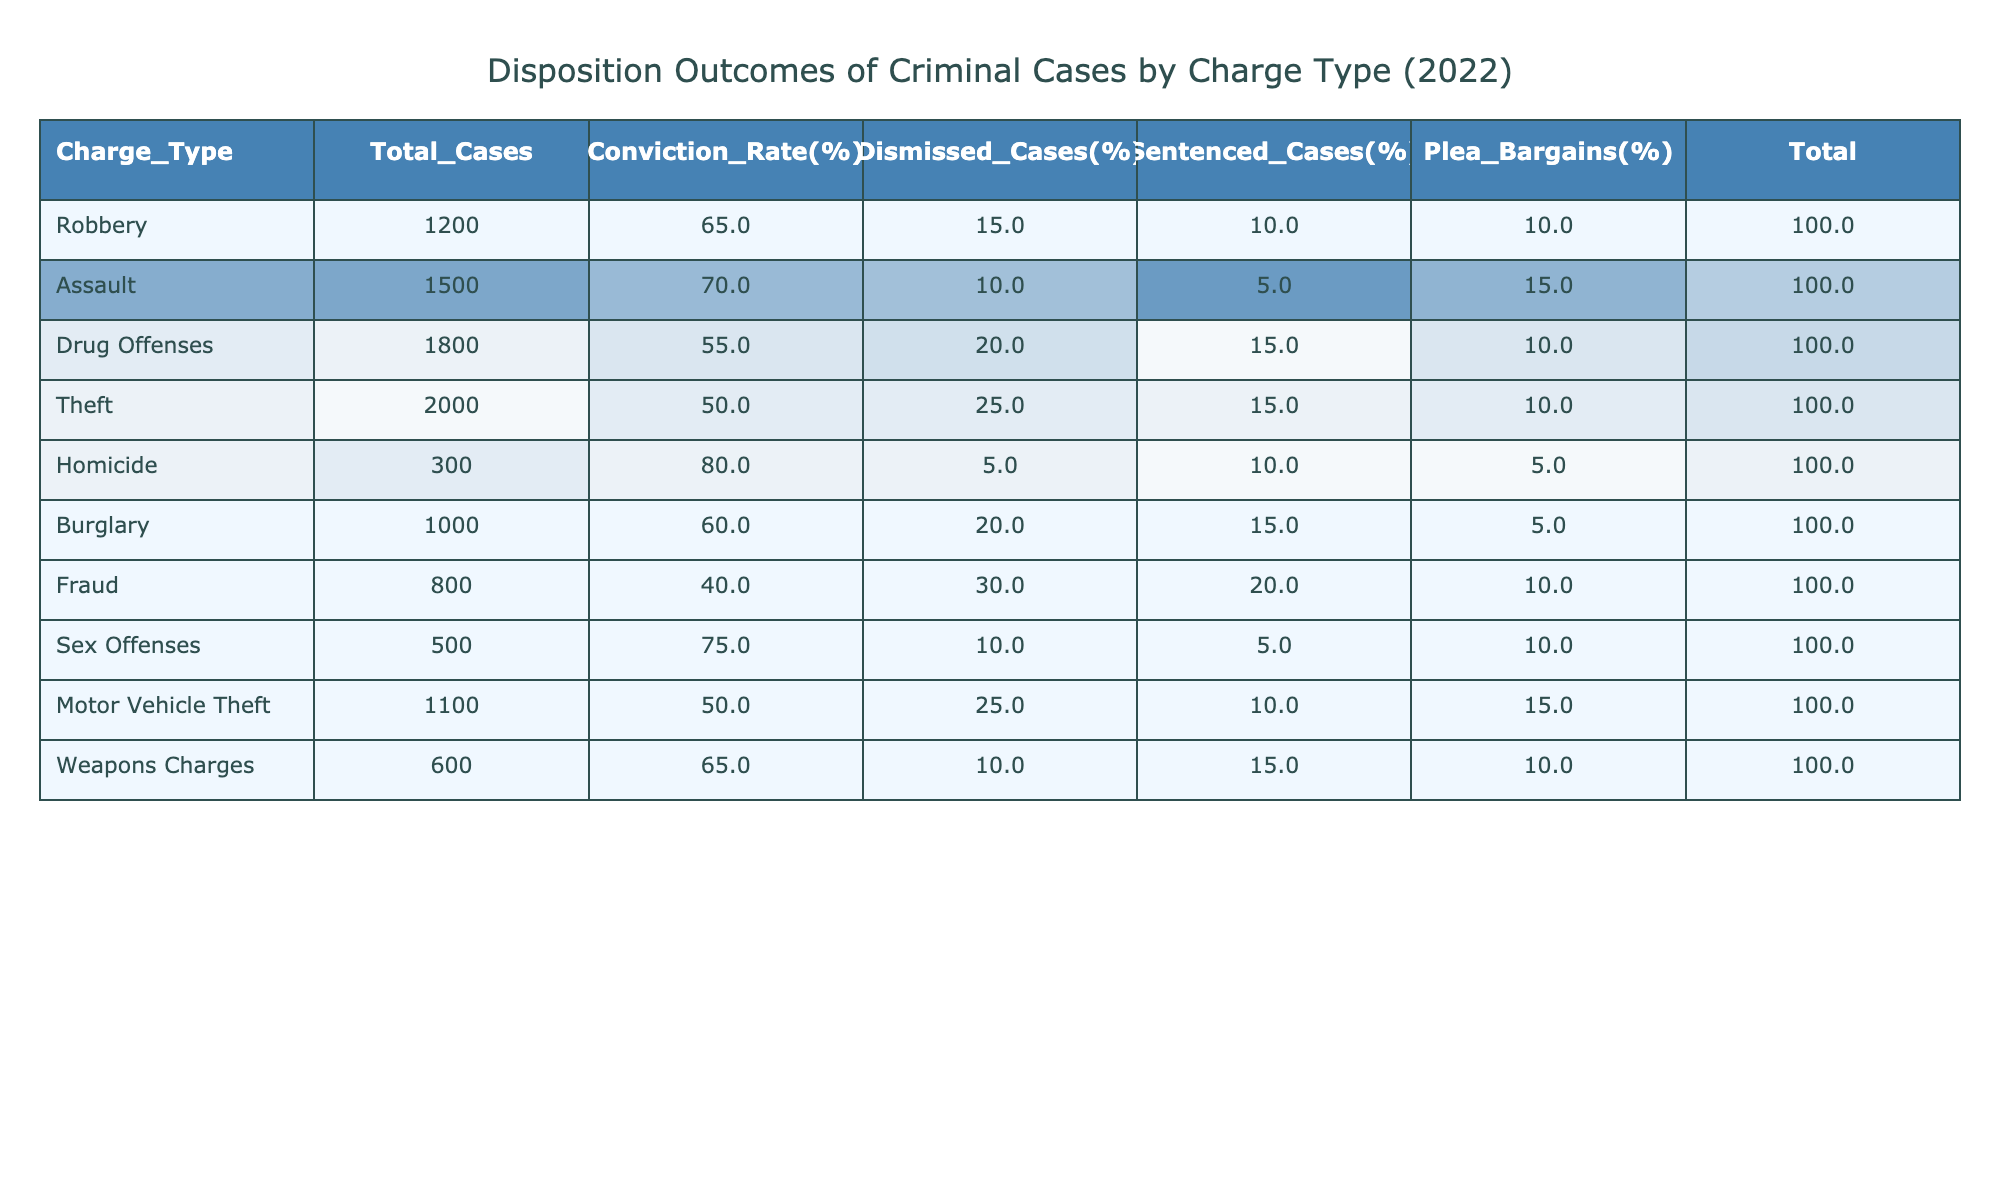What is the total number of robbery cases? The total number of robbery cases is indicated in the table under the 'Total_Cases' column for Robbery, which shows 1200 cases.
Answer: 1200 What percentage of drug offense cases were dismissed? To find the percentage of dismissed cases for drug offenses, refer to the 'Dismissed_Cases(%)' column for Drug Offenses, which shows 20%.
Answer: 20% Which charge type has the highest conviction rate? The conviction rate can be found in the 'Conviction_Rate(%)' column, where Homicide has the highest value at 80%.
Answer: Homicide How many total cases resulted in a plea bargain for assault? The total number of plea bargains can be found under the 'Plea_Bargains(%)' column for Assault, which states that 15% of the 1500 total Assault cases resulted in plea bargains. Thus, the calculation is 1500 * 0.15 = 225.
Answer: 225 What is the average conviction rate across all charge types? The conviction rates are: 65, 70, 55, 50, 80, 60, 40, 75, 50, and 65. Summing these gives 65 + 70 + 55 + 50 + 80 + 60 + 40 + 75 + 50 + 65 = 720. There are 10 charge types, so the average is 720 / 10 = 72.
Answer: 72 Which charge types have more than 1000 total cases and what is their average dismissal percentage? The charge types with more than 1000 cases are Robbery (1200), Assault (1500), Drug Offenses (1800), Theft (2000), and Motor Vehicle Theft (1100). Their dismissal percentages are 15%, 10%, 20%, 25%, and 25%, respectively. The average dismissal percentage is (15 + 10 + 20 + 25 + 25) / 5 = 19.
Answer: 19 Is the conviction rate for fraud lower than that of motor vehicle theft? The conviction rate for Fraud is 40%, and for Motor Vehicle Theft, it is 50%. Since 40% is lower than 50%, the statement is true.
Answer: Yes How many cases resulted in dismissal for burglary? The dismissal percentage for Burglary is 20% of the total 1000 cases, so the number of dismissed cases is 1000 * 0.20 = 200.
Answer: 200 What is the total number of sentenced cases for all charge types combined? To find the total sentenced cases, we can sum the 'Sentenced_Cases(%)' of each charge type. The total cases for sentenced are calculated as follows: (10% of 1200) + (5% of 1500) + (15% of 1800) + (15% of 2000) + (10% of 300) + (15% of 1000) + (20% of 800) + (5% of 500) + (10% of 1100) + (15% of 600), resulting in 120 + 75 + 270 + 300 + 30 + 150 + 160 + 25 + 110 + 90 = 1230.
Answer: 1230 Which charge type has the highest percentage of dismissed cases? Reviewing the 'Dismissed_Cases(%)' column, Fraud at 30% has the highest percentage of dismissed cases compared to other charge types.
Answer: Fraud 